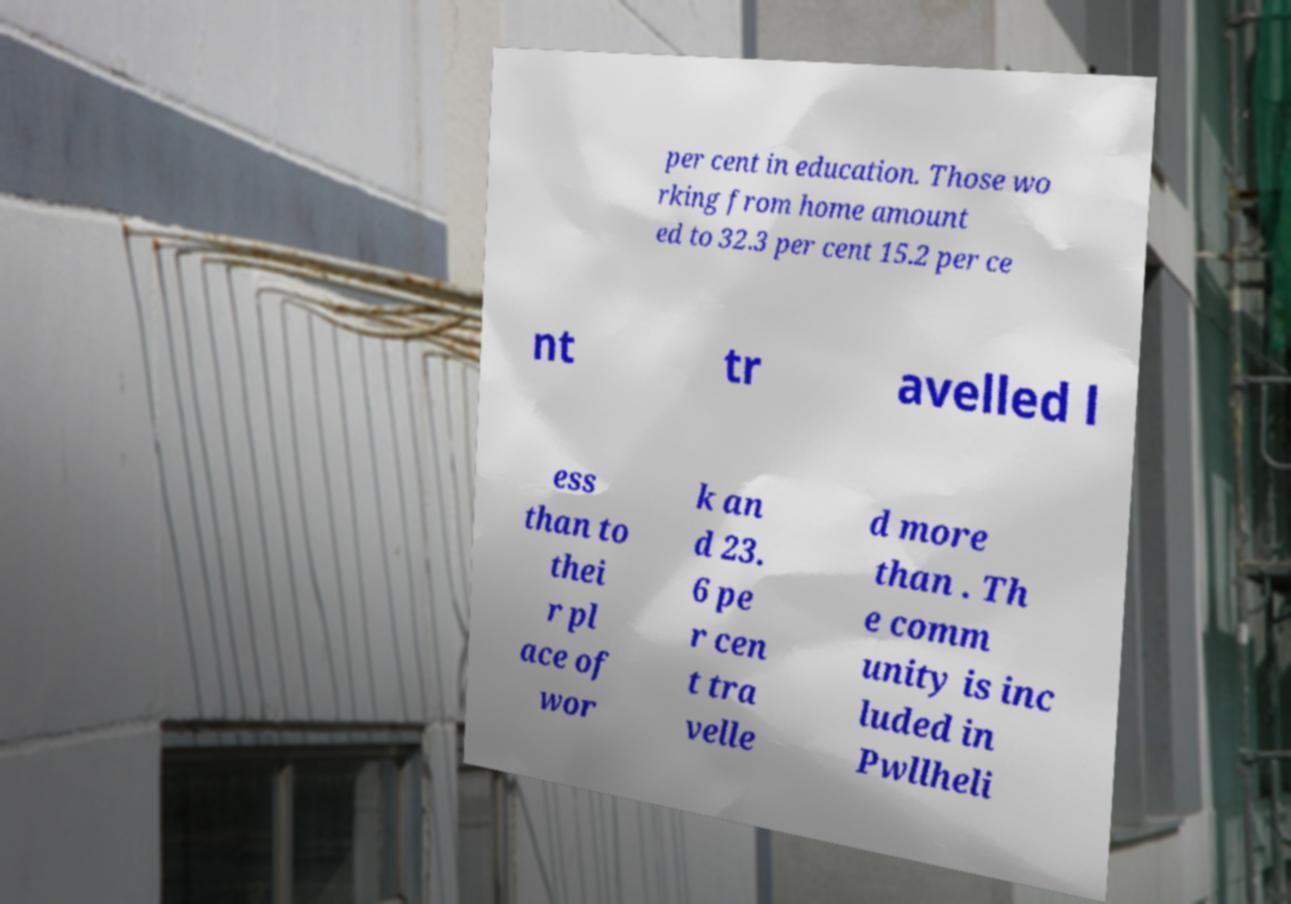Could you extract and type out the text from this image? per cent in education. Those wo rking from home amount ed to 32.3 per cent 15.2 per ce nt tr avelled l ess than to thei r pl ace of wor k an d 23. 6 pe r cen t tra velle d more than . Th e comm unity is inc luded in Pwllheli 